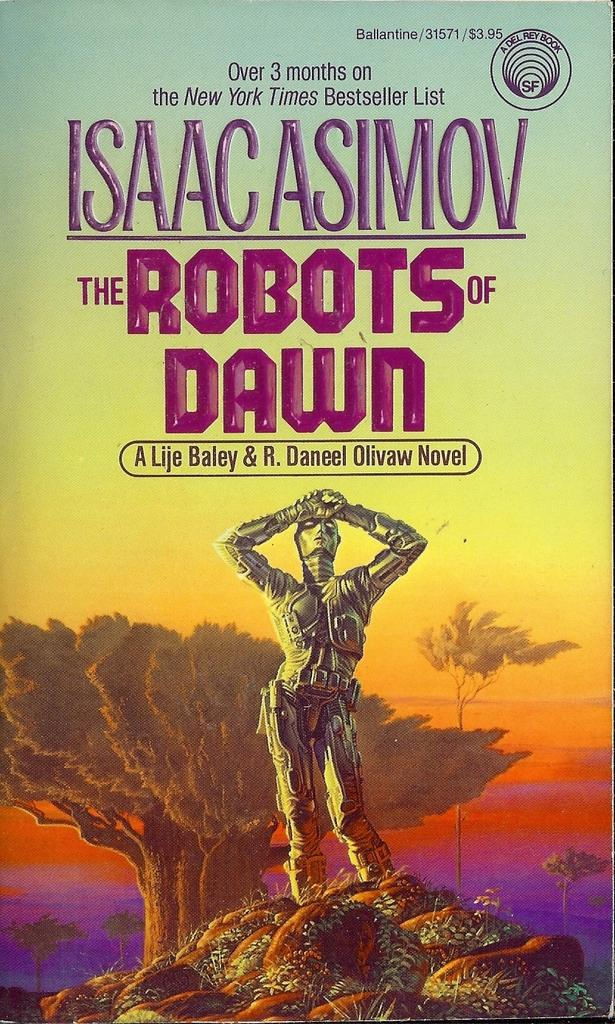<image>
Describe the image concisely. New York Times Bestseller Isaac Asimov's The Robots of Dawn featuring a silver robot. 